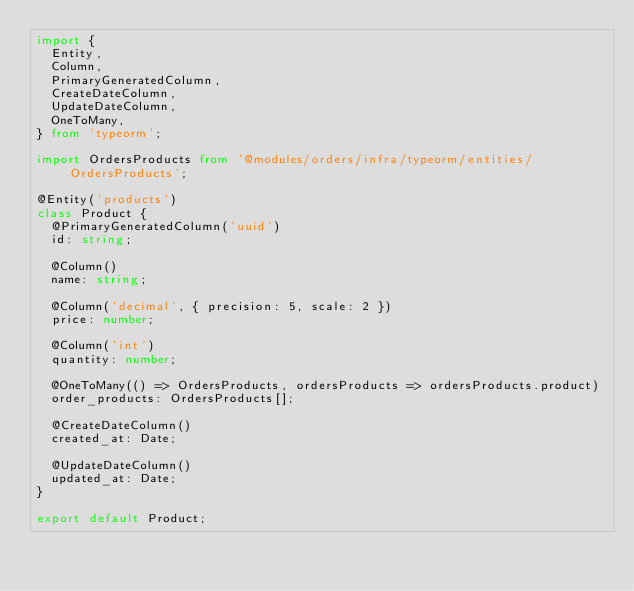<code> <loc_0><loc_0><loc_500><loc_500><_TypeScript_>import {
  Entity,
  Column,
  PrimaryGeneratedColumn,
  CreateDateColumn,
  UpdateDateColumn,
  OneToMany,
} from 'typeorm';

import OrdersProducts from '@modules/orders/infra/typeorm/entities/OrdersProducts';

@Entity('products')
class Product {
  @PrimaryGeneratedColumn('uuid')
  id: string;

  @Column()
  name: string;

  @Column('decimal', { precision: 5, scale: 2 })
  price: number;

  @Column('int')
  quantity: number;

  @OneToMany(() => OrdersProducts, ordersProducts => ordersProducts.product)
  order_products: OrdersProducts[];

  @CreateDateColumn()
  created_at: Date;

  @UpdateDateColumn()
  updated_at: Date;
}

export default Product;
</code> 